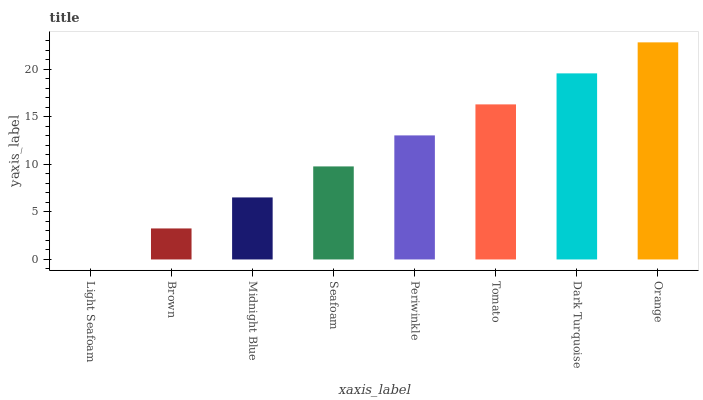Is Light Seafoam the minimum?
Answer yes or no. Yes. Is Orange the maximum?
Answer yes or no. Yes. Is Brown the minimum?
Answer yes or no. No. Is Brown the maximum?
Answer yes or no. No. Is Brown greater than Light Seafoam?
Answer yes or no. Yes. Is Light Seafoam less than Brown?
Answer yes or no. Yes. Is Light Seafoam greater than Brown?
Answer yes or no. No. Is Brown less than Light Seafoam?
Answer yes or no. No. Is Periwinkle the high median?
Answer yes or no. Yes. Is Seafoam the low median?
Answer yes or no. Yes. Is Orange the high median?
Answer yes or no. No. Is Periwinkle the low median?
Answer yes or no. No. 